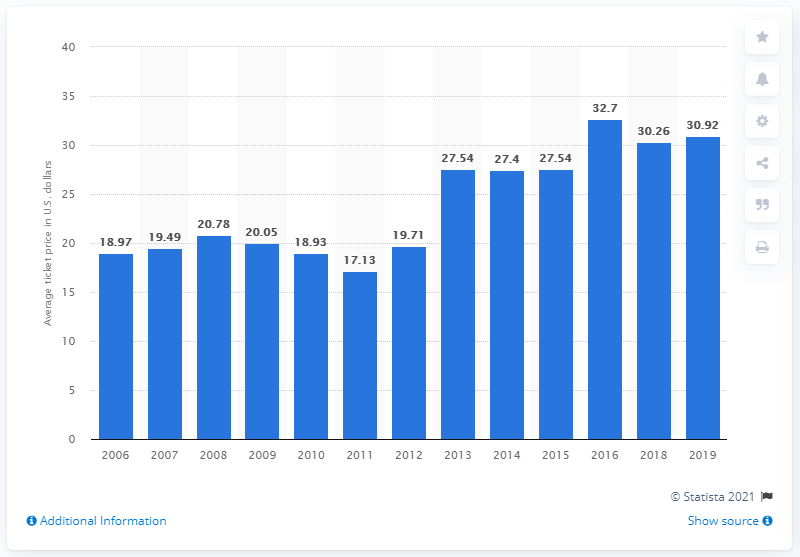Outline some significant characteristics in this image. In 2019, the average ticket price for Los Angeles Angels games was 30.92. 